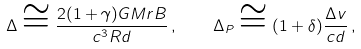<formula> <loc_0><loc_0><loc_500><loc_500>\Delta \cong \frac { 2 ( 1 + \gamma ) G M r B } { c ^ { 3 } R d } \, , \quad \Delta _ { P } \cong ( 1 + \delta ) \frac { \Delta v } { c d } \, ,</formula> 